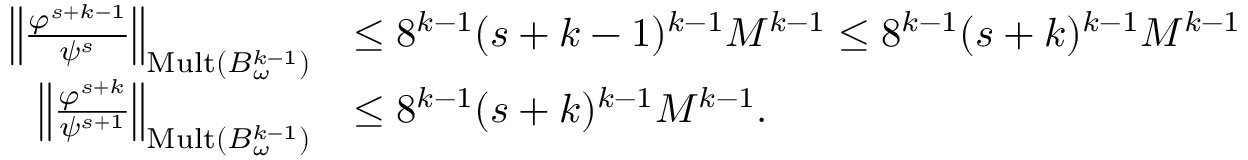Convert formula to latex. <formula><loc_0><loc_0><loc_500><loc_500>\begin{array} { r l } { \left \| \frac { \varphi ^ { s + k - 1 } } { \psi ^ { s } } \right \| _ { M u l t ( B _ { \omega } ^ { k - 1 } ) } } & { \leq 8 ^ { k - 1 } ( s + k - 1 ) ^ { k - 1 } M ^ { k - 1 } \leq 8 ^ { k - 1 } ( s + k ) ^ { k - 1 } M ^ { k - 1 } } \\ { \left \| \frac { \varphi ^ { s + k } } { \psi ^ { s + 1 } } \right \| _ { M u l t ( B _ { \omega } ^ { k - 1 } ) } } & { \leq 8 ^ { k - 1 } ( s + k ) ^ { k - 1 } M ^ { k - 1 } . } \end{array}</formula> 